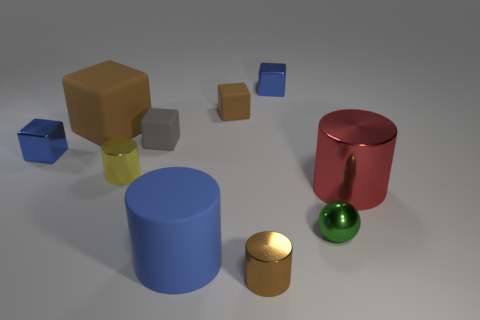Is there any other thing of the same color as the large metal object?
Provide a short and direct response. No. What shape is the big thing that is the same material as the brown cylinder?
Provide a short and direct response. Cylinder. What is the size of the yellow metallic cylinder in front of the small gray rubber block?
Make the answer very short. Small. What is the shape of the large blue object?
Keep it short and to the point. Cylinder. There is a blue metallic block that is left of the brown cylinder; is its size the same as the brown matte block that is to the right of the tiny yellow thing?
Your answer should be very brief. Yes. There is a metal cylinder that is in front of the small metallic ball that is right of the cylinder that is left of the blue rubber cylinder; what size is it?
Give a very brief answer. Small. There is a small blue object that is left of the tiny blue metallic thing to the right of the big matte object that is behind the gray cube; what is its shape?
Offer a terse response. Cube. There is a small rubber thing that is on the right side of the big rubber cylinder; what is its shape?
Your answer should be very brief. Cube. Does the blue cylinder have the same material as the object on the right side of the small shiny sphere?
Your answer should be compact. No. How many other things are the same shape as the small green shiny object?
Keep it short and to the point. 0. 